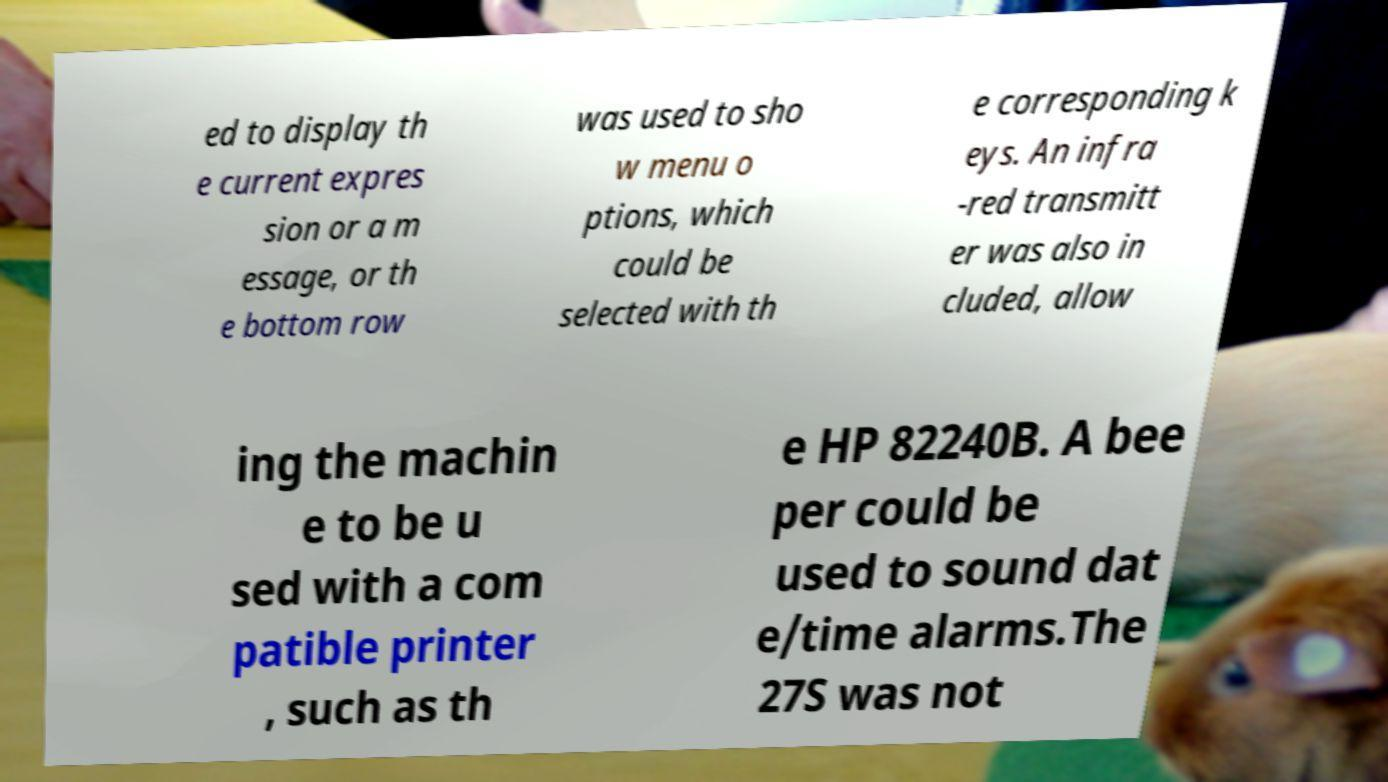For documentation purposes, I need the text within this image transcribed. Could you provide that? ed to display th e current expres sion or a m essage, or th e bottom row was used to sho w menu o ptions, which could be selected with th e corresponding k eys. An infra -red transmitt er was also in cluded, allow ing the machin e to be u sed with a com patible printer , such as th e HP 82240B. A bee per could be used to sound dat e/time alarms.The 27S was not 